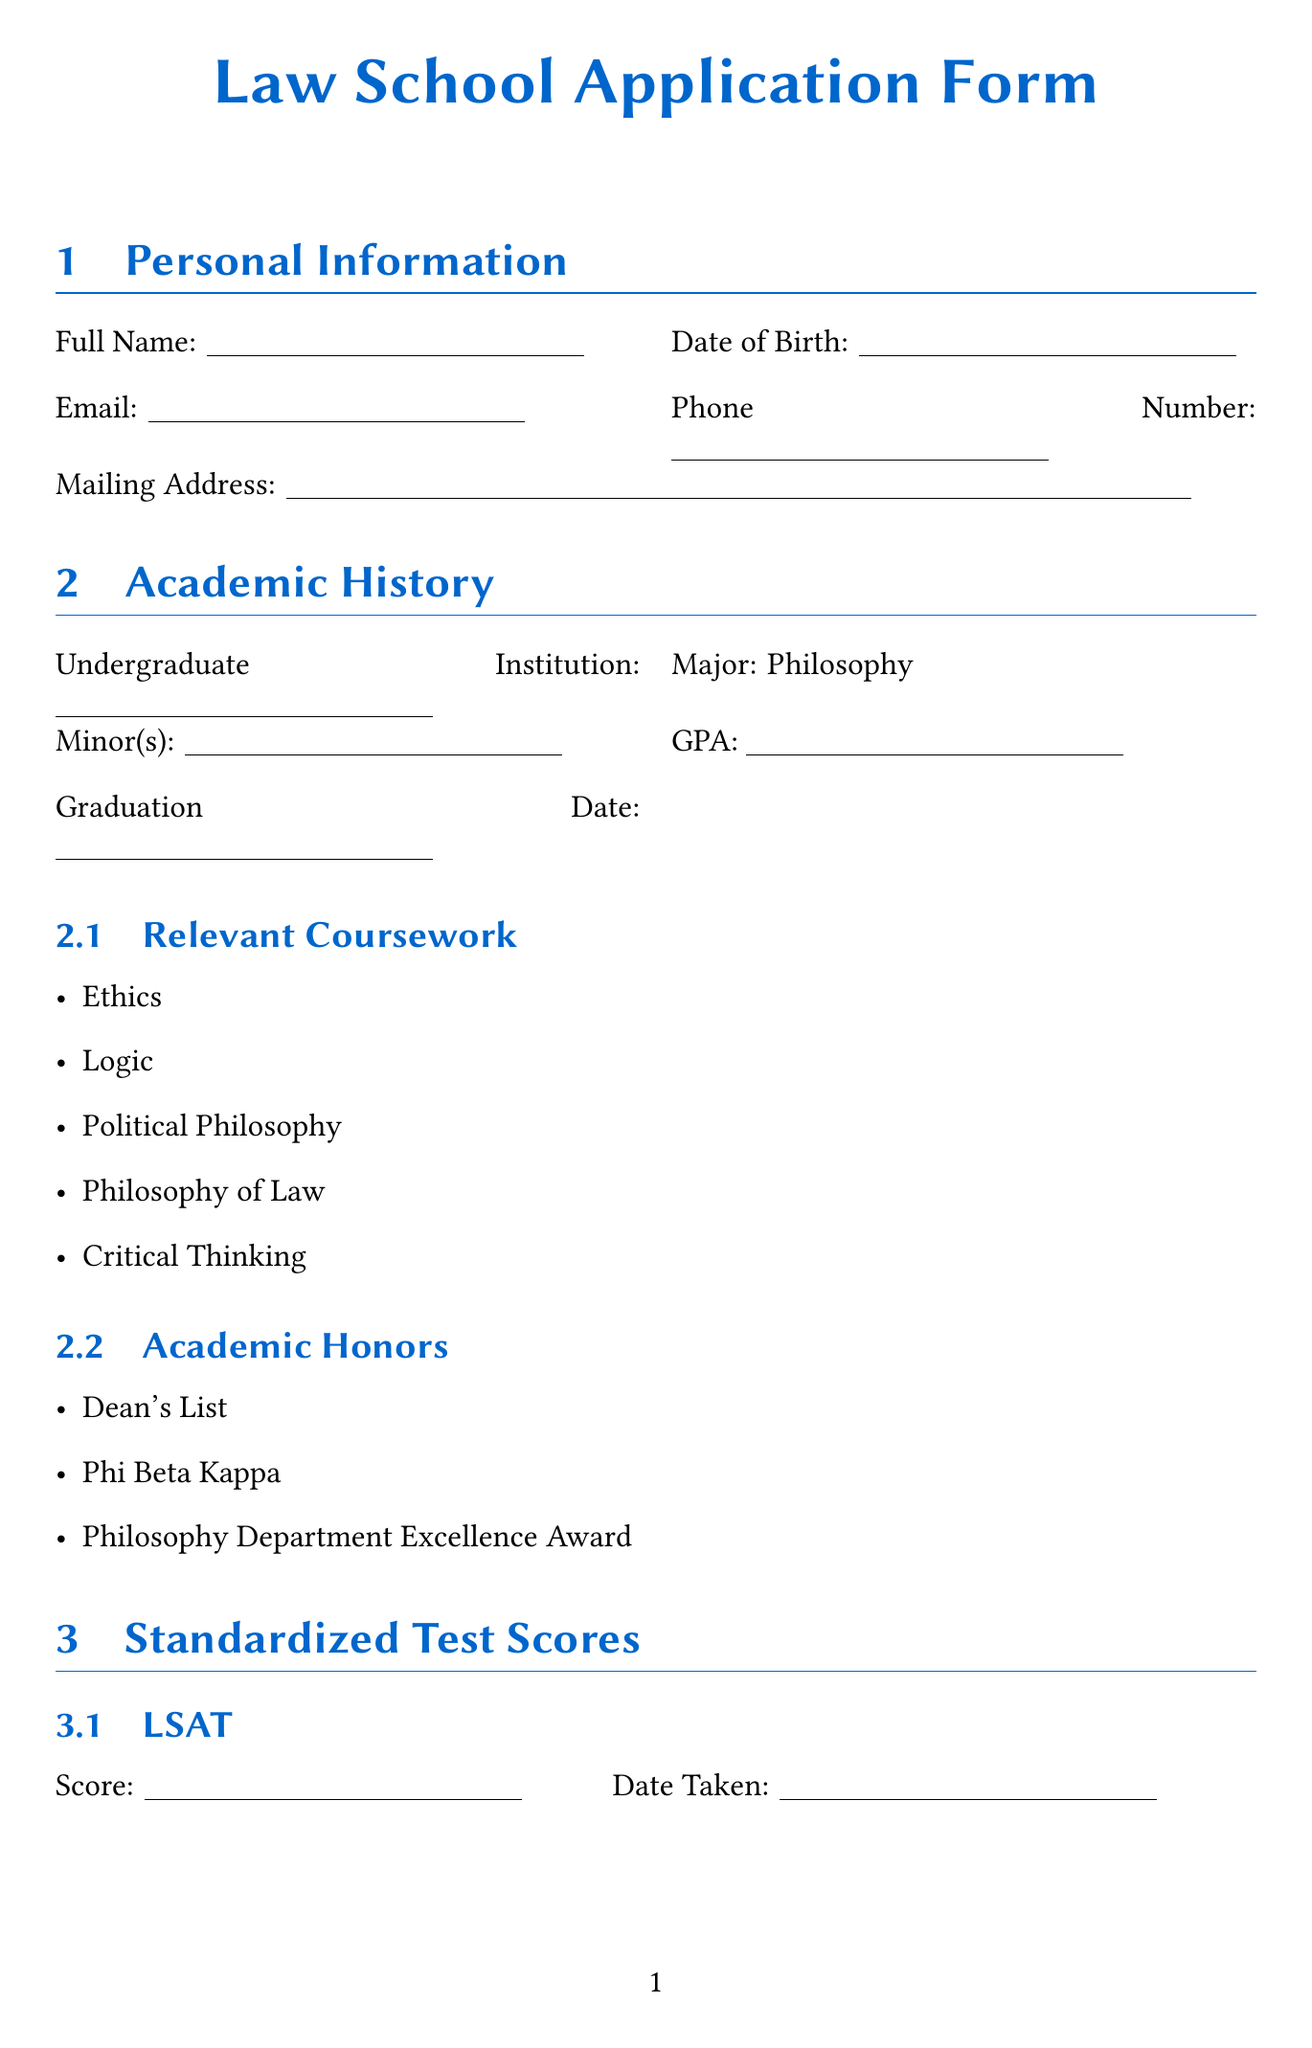what is the applicant's major? The applicant's major is listed in the academic history section of the document.
Answer: Philosophy what is the date taken for the LSAT? The document includes a section for standardized test scores, specifically for the LSAT date taken.
Answer: (blank space) how many academic honors are listed? The academic honors section indicates specific recognitions received by the applicant.
Answer: 3 what are the three program preferences? The program preference section outlines the applicant's choices for law programs.
Answer: Public Interest Law, Human Rights Law, Environmental Law what is the prompt for the personal statement? The prompt is explicitly stated in the personal statement section of the document.
Answer: In 500-750 words, please describe your motivation for pursuing a law degree, your interest in non-profit organizations, and how your background in philosophy has prepared you for a career in law who is the first recommender? The document requires the name of the first recommender in the letters of recommendation section.
Answer: (blank space) is the applicant applying for need-based aid? The financial aid section specifies whether the applicant is applying for need-based aid.
Answer: Yes what is the name of the scholarship related to non-profit law? The merit-based scholarships section lists the scholarships the applicant is applying for.
Answer: Public Interest Law Scholarship what languages are mentioned in the language proficiency section? The language proficiency section includes details about the languages spoken by the applicant.
Answer: (blank space) what is the total length requirement for the personal statement? The personal statement section specifies the word count requirement for the essay.
Answer: 500-750 words 